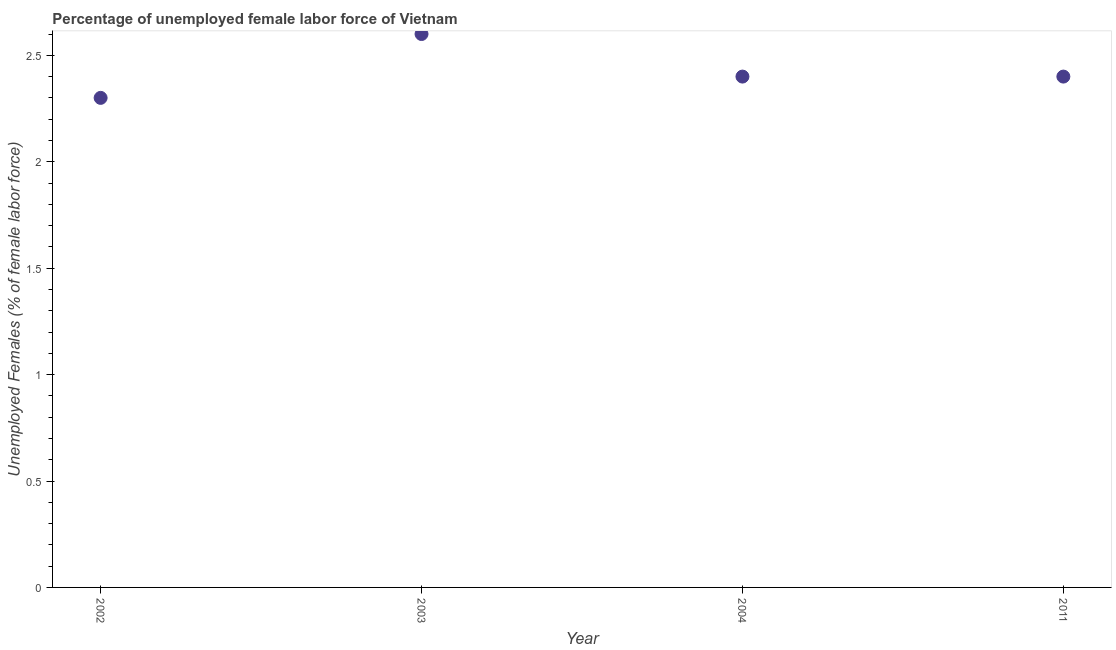What is the total unemployed female labour force in 2003?
Ensure brevity in your answer.  2.6. Across all years, what is the maximum total unemployed female labour force?
Provide a short and direct response. 2.6. Across all years, what is the minimum total unemployed female labour force?
Offer a very short reply. 2.3. In which year was the total unemployed female labour force minimum?
Give a very brief answer. 2002. What is the sum of the total unemployed female labour force?
Provide a short and direct response. 9.7. What is the difference between the total unemployed female labour force in 2004 and 2011?
Keep it short and to the point. 0. What is the average total unemployed female labour force per year?
Offer a very short reply. 2.43. What is the median total unemployed female labour force?
Provide a succinct answer. 2.4. In how many years, is the total unemployed female labour force greater than 0.8 %?
Keep it short and to the point. 4. What is the ratio of the total unemployed female labour force in 2002 to that in 2004?
Make the answer very short. 0.96. What is the difference between the highest and the second highest total unemployed female labour force?
Provide a short and direct response. 0.2. What is the difference between the highest and the lowest total unemployed female labour force?
Your answer should be very brief. 0.3. How many dotlines are there?
Make the answer very short. 1. What is the difference between two consecutive major ticks on the Y-axis?
Offer a terse response. 0.5. Does the graph contain any zero values?
Make the answer very short. No. Does the graph contain grids?
Your response must be concise. No. What is the title of the graph?
Your answer should be compact. Percentage of unemployed female labor force of Vietnam. What is the label or title of the X-axis?
Your answer should be compact. Year. What is the label or title of the Y-axis?
Give a very brief answer. Unemployed Females (% of female labor force). What is the Unemployed Females (% of female labor force) in 2002?
Give a very brief answer. 2.3. What is the Unemployed Females (% of female labor force) in 2003?
Give a very brief answer. 2.6. What is the Unemployed Females (% of female labor force) in 2004?
Offer a very short reply. 2.4. What is the Unemployed Females (% of female labor force) in 2011?
Provide a succinct answer. 2.4. What is the difference between the Unemployed Females (% of female labor force) in 2003 and 2004?
Provide a succinct answer. 0.2. What is the difference between the Unemployed Females (% of female labor force) in 2004 and 2011?
Ensure brevity in your answer.  0. What is the ratio of the Unemployed Females (% of female labor force) in 2002 to that in 2003?
Keep it short and to the point. 0.89. What is the ratio of the Unemployed Females (% of female labor force) in 2002 to that in 2004?
Offer a terse response. 0.96. What is the ratio of the Unemployed Females (% of female labor force) in 2002 to that in 2011?
Your answer should be compact. 0.96. What is the ratio of the Unemployed Females (% of female labor force) in 2003 to that in 2004?
Your answer should be compact. 1.08. What is the ratio of the Unemployed Females (% of female labor force) in 2003 to that in 2011?
Your answer should be very brief. 1.08. 